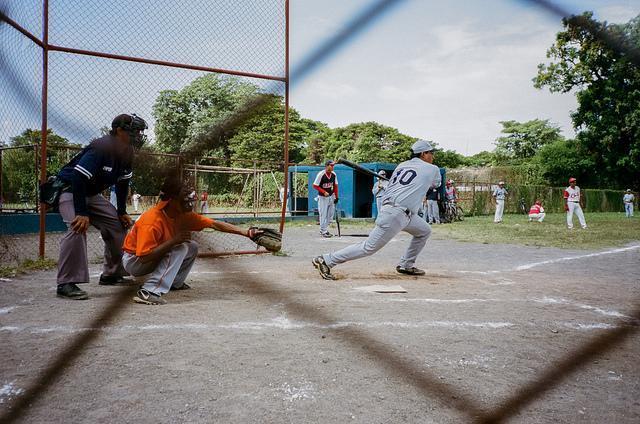How many people can you see?
Give a very brief answer. 3. 